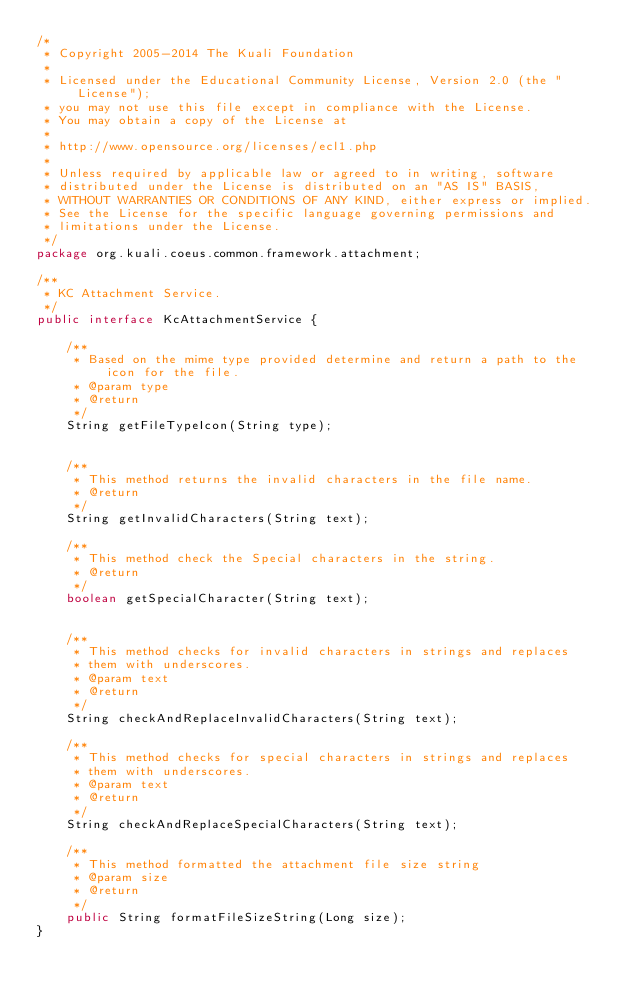<code> <loc_0><loc_0><loc_500><loc_500><_Java_>/*
 * Copyright 2005-2014 The Kuali Foundation
 * 
 * Licensed under the Educational Community License, Version 2.0 (the "License");
 * you may not use this file except in compliance with the License.
 * You may obtain a copy of the License at
 * 
 * http://www.opensource.org/licenses/ecl1.php
 * 
 * Unless required by applicable law or agreed to in writing, software
 * distributed under the License is distributed on an "AS IS" BASIS,
 * WITHOUT WARRANTIES OR CONDITIONS OF ANY KIND, either express or implied.
 * See the License for the specific language governing permissions and
 * limitations under the License.
 */
package org.kuali.coeus.common.framework.attachment;

/**
 * KC Attachment Service.
 */
public interface KcAttachmentService {

    /**
     * Based on the mime type provided determine and return a path to the icon for the file.
     * @param type
     * @return
     */
    String getFileTypeIcon(String type);
   
    
    /**
     * This method returns the invalid characters in the file name.
     * @return
     */
    String getInvalidCharacters(String text);
    
    /**
     * This method check the Special characters in the string.
     * @return
     */
    boolean getSpecialCharacter(String text);
   
        
    /**
     * This method checks for invalid characters in strings and replaces
     * them with underscores.
     * @param text
     * @return
     */
    String checkAndReplaceInvalidCharacters(String text);
    
    /**
     * This method checks for special characters in strings and replaces
     * them with underscores.
     * @param text
     * @return
     */
    String checkAndReplaceSpecialCharacters(String text);

    /**
     * This method formatted the attachment file size string
     * @param size
     * @return
     */
    public String formatFileSizeString(Long size);
}
</code> 